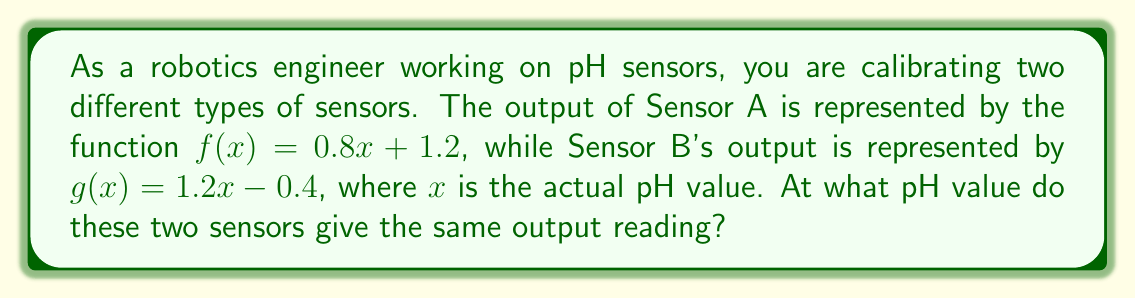Help me with this question. To find the pH value where both sensors give the same output, we need to find the intersection point of the two linear functions. This can be done by setting the two functions equal to each other and solving for x.

1) Set the functions equal:
   $f(x) = g(x)$
   $0.8x + 1.2 = 1.2x - 0.4$

2) Subtract $0.8x$ from both sides:
   $1.2 = 0.4x - 0.4$

3) Add 0.4 to both sides:
   $1.6 = 0.4x$

4) Divide both sides by 0.4:
   $4 = x$

5) Check the solution by plugging x = 4 into both original functions:
   $f(4) = 0.8(4) + 1.2 = 3.2 + 1.2 = 4.4$
   $g(4) = 1.2(4) - 0.4 = 4.8 - 0.4 = 4.4$

Both functions yield the same output (4.4) when x = 4, confirming our solution.
Answer: The two sensors give the same output reading at a pH value of 4. 